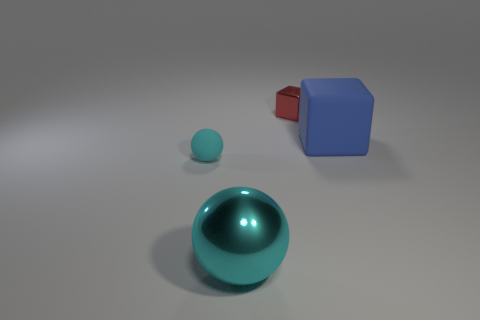Add 2 tiny cyan rubber objects. How many objects exist? 6 Subtract 1 cyan spheres. How many objects are left? 3 Subtract all big green matte objects. Subtract all shiny cubes. How many objects are left? 3 Add 2 tiny spheres. How many tiny spheres are left? 3 Add 1 metal things. How many metal things exist? 3 